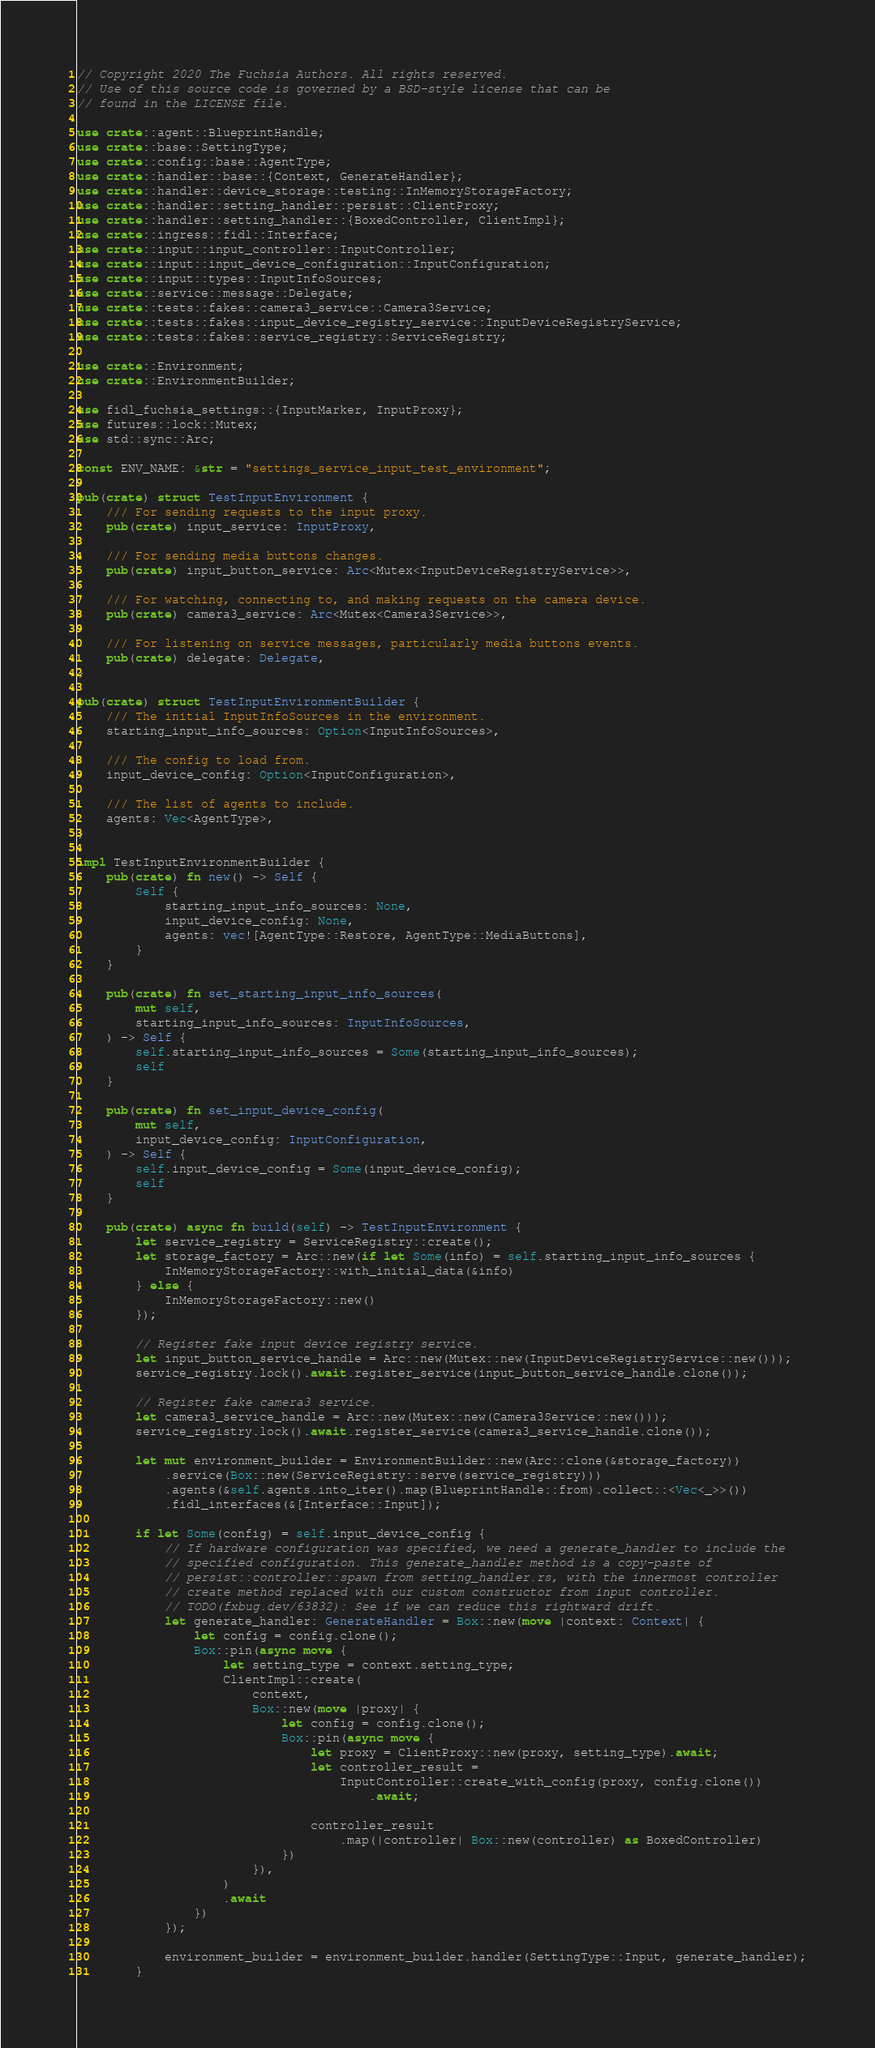Convert code to text. <code><loc_0><loc_0><loc_500><loc_500><_Rust_>// Copyright 2020 The Fuchsia Authors. All rights reserved.
// Use of this source code is governed by a BSD-style license that can be
// found in the LICENSE file.

use crate::agent::BlueprintHandle;
use crate::base::SettingType;
use crate::config::base::AgentType;
use crate::handler::base::{Context, GenerateHandler};
use crate::handler::device_storage::testing::InMemoryStorageFactory;
use crate::handler::setting_handler::persist::ClientProxy;
use crate::handler::setting_handler::{BoxedController, ClientImpl};
use crate::ingress::fidl::Interface;
use crate::input::input_controller::InputController;
use crate::input::input_device_configuration::InputConfiguration;
use crate::input::types::InputInfoSources;
use crate::service::message::Delegate;
use crate::tests::fakes::camera3_service::Camera3Service;
use crate::tests::fakes::input_device_registry_service::InputDeviceRegistryService;
use crate::tests::fakes::service_registry::ServiceRegistry;

use crate::Environment;
use crate::EnvironmentBuilder;

use fidl_fuchsia_settings::{InputMarker, InputProxy};
use futures::lock::Mutex;
use std::sync::Arc;

const ENV_NAME: &str = "settings_service_input_test_environment";

pub(crate) struct TestInputEnvironment {
    /// For sending requests to the input proxy.
    pub(crate) input_service: InputProxy,

    /// For sending media buttons changes.
    pub(crate) input_button_service: Arc<Mutex<InputDeviceRegistryService>>,

    /// For watching, connecting to, and making requests on the camera device.
    pub(crate) camera3_service: Arc<Mutex<Camera3Service>>,

    /// For listening on service messages, particularly media buttons events.
    pub(crate) delegate: Delegate,
}

pub(crate) struct TestInputEnvironmentBuilder {
    /// The initial InputInfoSources in the environment.
    starting_input_info_sources: Option<InputInfoSources>,

    /// The config to load from.
    input_device_config: Option<InputConfiguration>,

    /// The list of agents to include.
    agents: Vec<AgentType>,
}

impl TestInputEnvironmentBuilder {
    pub(crate) fn new() -> Self {
        Self {
            starting_input_info_sources: None,
            input_device_config: None,
            agents: vec![AgentType::Restore, AgentType::MediaButtons],
        }
    }

    pub(crate) fn set_starting_input_info_sources(
        mut self,
        starting_input_info_sources: InputInfoSources,
    ) -> Self {
        self.starting_input_info_sources = Some(starting_input_info_sources);
        self
    }

    pub(crate) fn set_input_device_config(
        mut self,
        input_device_config: InputConfiguration,
    ) -> Self {
        self.input_device_config = Some(input_device_config);
        self
    }

    pub(crate) async fn build(self) -> TestInputEnvironment {
        let service_registry = ServiceRegistry::create();
        let storage_factory = Arc::new(if let Some(info) = self.starting_input_info_sources {
            InMemoryStorageFactory::with_initial_data(&info)
        } else {
            InMemoryStorageFactory::new()
        });

        // Register fake input device registry service.
        let input_button_service_handle = Arc::new(Mutex::new(InputDeviceRegistryService::new()));
        service_registry.lock().await.register_service(input_button_service_handle.clone());

        // Register fake camera3 service.
        let camera3_service_handle = Arc::new(Mutex::new(Camera3Service::new()));
        service_registry.lock().await.register_service(camera3_service_handle.clone());

        let mut environment_builder = EnvironmentBuilder::new(Arc::clone(&storage_factory))
            .service(Box::new(ServiceRegistry::serve(service_registry)))
            .agents(&self.agents.into_iter().map(BlueprintHandle::from).collect::<Vec<_>>())
            .fidl_interfaces(&[Interface::Input]);

        if let Some(config) = self.input_device_config {
            // If hardware configuration was specified, we need a generate_handler to include the
            // specified configuration. This generate_handler method is a copy-paste of
            // persist::controller::spawn from setting_handler.rs, with the innermost controller
            // create method replaced with our custom constructor from input controller.
            // TODO(fxbug.dev/63832): See if we can reduce this rightward drift.
            let generate_handler: GenerateHandler = Box::new(move |context: Context| {
                let config = config.clone();
                Box::pin(async move {
                    let setting_type = context.setting_type;
                    ClientImpl::create(
                        context,
                        Box::new(move |proxy| {
                            let config = config.clone();
                            Box::pin(async move {
                                let proxy = ClientProxy::new(proxy, setting_type).await;
                                let controller_result =
                                    InputController::create_with_config(proxy, config.clone())
                                        .await;

                                controller_result
                                    .map(|controller| Box::new(controller) as BoxedController)
                            })
                        }),
                    )
                    .await
                })
            });

            environment_builder = environment_builder.handler(SettingType::Input, generate_handler);
        }
</code> 